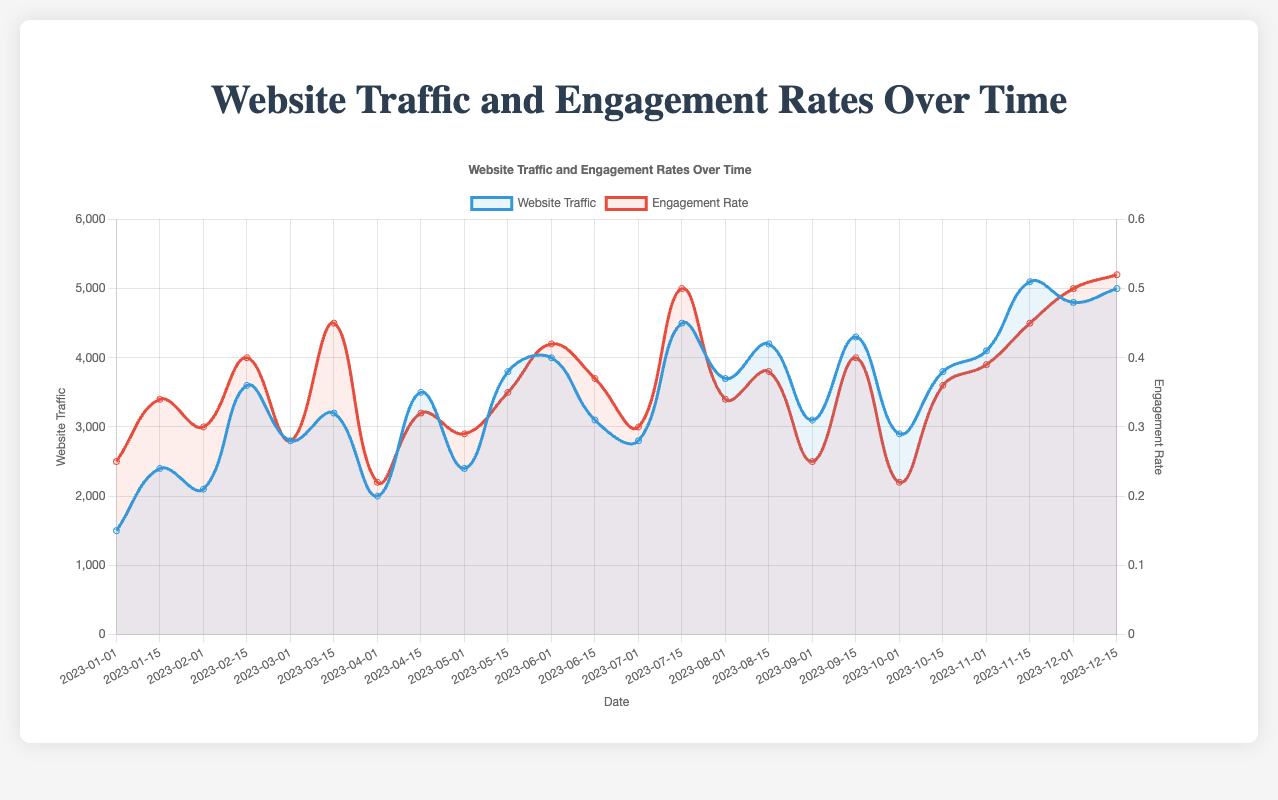What was the date with the highest engagement rate? Looking at the red curve representing the engagement rate, the highest point occurs at the last data point. This corresponds to the date "2023-12-15" in the data.
Answer: 2023-12-15 Which campaign had the highest website traffic? Observing the blue curve for website traffic, the highest peak corresponds to the point in mid-November 2023. Referring to the data, the peak traffic of 5100 occurred for the "Black Friday Deals" campaign on 2023-11-15.
Answer: Black Friday Deals When did the "Valentine's Day Special" campaign take place, and what was its engagement rate? The "Valentine's Day Special" campaign is identified in the data and corresponds to the date "2023-02-15". The engagement rate for this date is given as 0.40.
Answer: 2023-02-15, 0.40 What's the average engagement rate across all campaigns? To find the average engagement rate, sum all engagement rates and then divide by the number of data points. The engagement rates summed up are 9.88, and there are 24 data points: 9.88/24 = 0.41
Answer: 0.41 Compare the traffic levels for the "Summer Preview" and "Autumn Sale" campaigns. Which one was higher, and by how much? "Summer Preview" is on 2023-05-15 with a traffic of 3800, and "Autumn Sale" is on 2023-09-01 with a traffic of 3100. The difference is 3800 - 3100 = 700. So, "Summer Preview" had higher traffic by 700.
Answer: Summer Preview, 700 Did the "Halloween Preview" campaign have a higher engagement rate than the "October Fest" campaign? The "Halloween Preview" campaign on 2023-10-15 had an engagement rate of 0.36, while the "October Fest" campaign on 2023-10-01 had an engagement rate of 0.22. Comparing these, 0.36 is greater than 0.22.
Answer: Yes What are the two campaigns with the lowest engagement rates, and what were their engagement rates? By looking at the lowest points on the red curve, we find "April Fools' Specials" on 2023-04-01 with 0.22 and "October Fest" on 2023-10-01 also with 0.22.
Answer: "April Fools' Specials" and "October Fest", both 0.22 Which month had the highest total website traffic, and what was the total? Summing up the traffic for each month, November has the highest total: 4100 (11-01) + 5100 (11-15) = 9200, which makes it the highest among all months.
Answer: November, 9200 